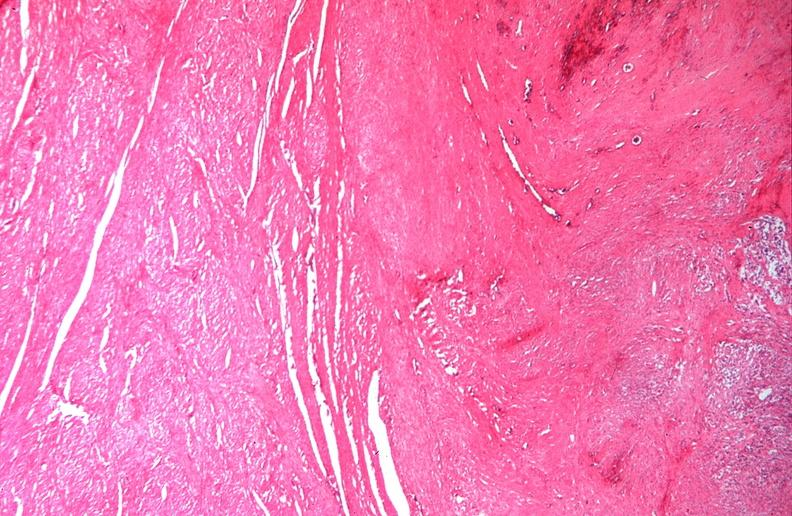what does this image show?
Answer the question using a single word or phrase. Uterus 